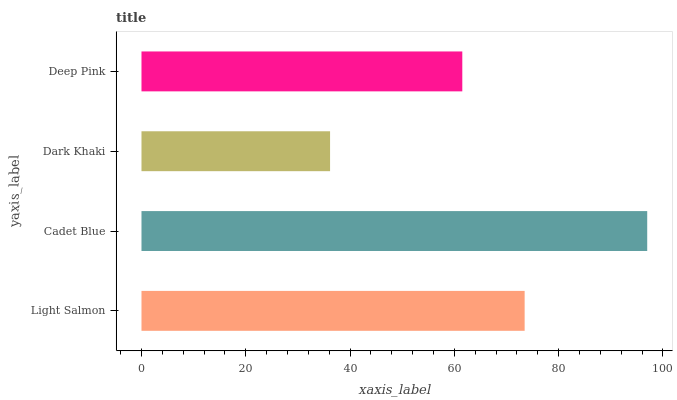Is Dark Khaki the minimum?
Answer yes or no. Yes. Is Cadet Blue the maximum?
Answer yes or no. Yes. Is Cadet Blue the minimum?
Answer yes or no. No. Is Dark Khaki the maximum?
Answer yes or no. No. Is Cadet Blue greater than Dark Khaki?
Answer yes or no. Yes. Is Dark Khaki less than Cadet Blue?
Answer yes or no. Yes. Is Dark Khaki greater than Cadet Blue?
Answer yes or no. No. Is Cadet Blue less than Dark Khaki?
Answer yes or no. No. Is Light Salmon the high median?
Answer yes or no. Yes. Is Deep Pink the low median?
Answer yes or no. Yes. Is Cadet Blue the high median?
Answer yes or no. No. Is Cadet Blue the low median?
Answer yes or no. No. 